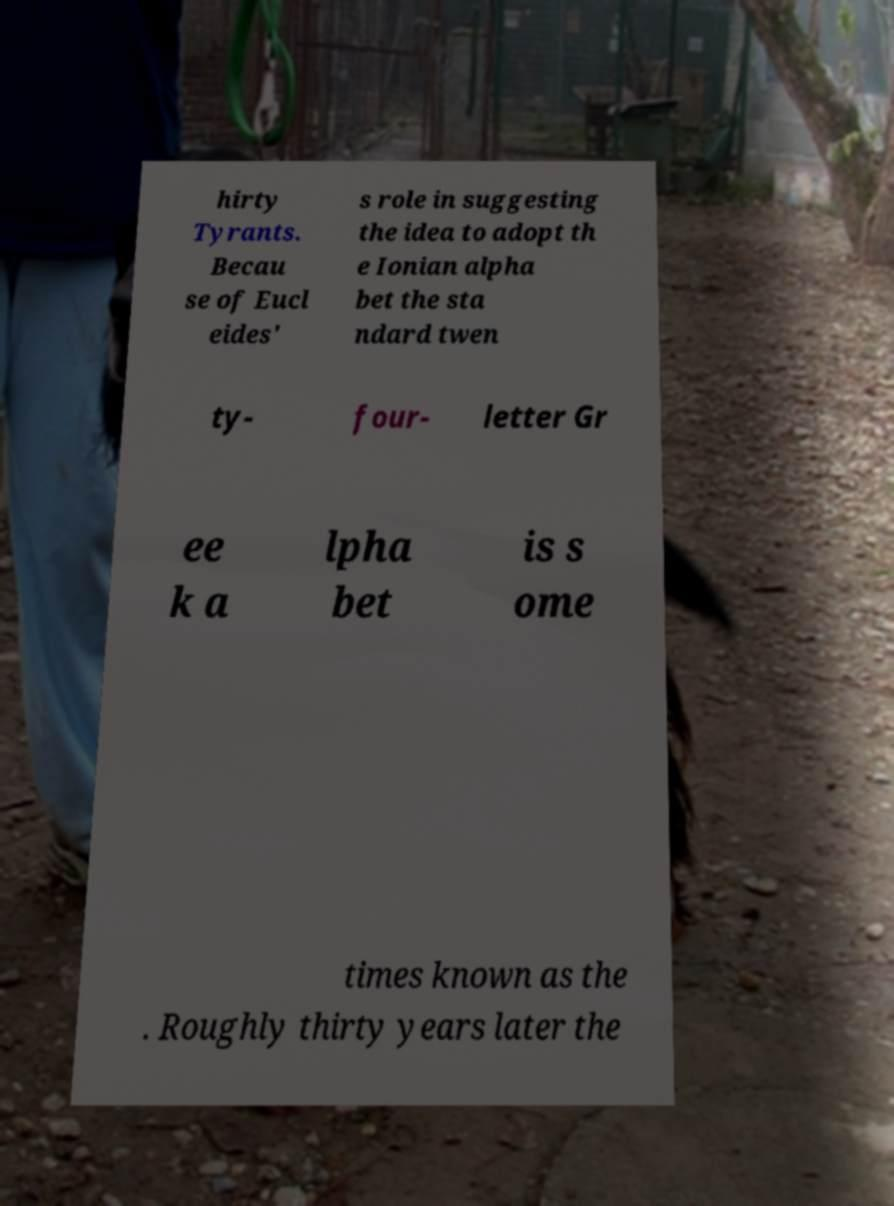Please read and relay the text visible in this image. What does it say? hirty Tyrants. Becau se of Eucl eides' s role in suggesting the idea to adopt th e Ionian alpha bet the sta ndard twen ty- four- letter Gr ee k a lpha bet is s ome times known as the . Roughly thirty years later the 